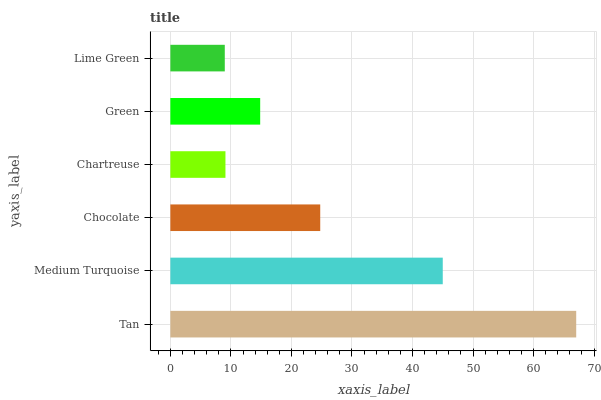Is Lime Green the minimum?
Answer yes or no. Yes. Is Tan the maximum?
Answer yes or no. Yes. Is Medium Turquoise the minimum?
Answer yes or no. No. Is Medium Turquoise the maximum?
Answer yes or no. No. Is Tan greater than Medium Turquoise?
Answer yes or no. Yes. Is Medium Turquoise less than Tan?
Answer yes or no. Yes. Is Medium Turquoise greater than Tan?
Answer yes or no. No. Is Tan less than Medium Turquoise?
Answer yes or no. No. Is Chocolate the high median?
Answer yes or no. Yes. Is Green the low median?
Answer yes or no. Yes. Is Green the high median?
Answer yes or no. No. Is Chartreuse the low median?
Answer yes or no. No. 